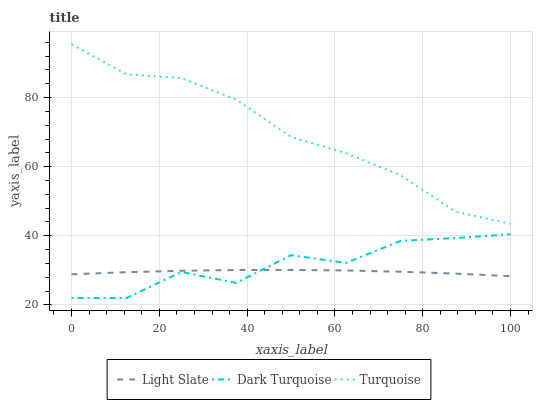Does Light Slate have the minimum area under the curve?
Answer yes or no. Yes. Does Turquoise have the maximum area under the curve?
Answer yes or no. Yes. Does Dark Turquoise have the minimum area under the curve?
Answer yes or no. No. Does Dark Turquoise have the maximum area under the curve?
Answer yes or no. No. Is Light Slate the smoothest?
Answer yes or no. Yes. Is Dark Turquoise the roughest?
Answer yes or no. Yes. Is Turquoise the smoothest?
Answer yes or no. No. Is Turquoise the roughest?
Answer yes or no. No. Does Dark Turquoise have the lowest value?
Answer yes or no. Yes. Does Turquoise have the lowest value?
Answer yes or no. No. Does Turquoise have the highest value?
Answer yes or no. Yes. Does Dark Turquoise have the highest value?
Answer yes or no. No. Is Dark Turquoise less than Turquoise?
Answer yes or no. Yes. Is Turquoise greater than Light Slate?
Answer yes or no. Yes. Does Light Slate intersect Dark Turquoise?
Answer yes or no. Yes. Is Light Slate less than Dark Turquoise?
Answer yes or no. No. Is Light Slate greater than Dark Turquoise?
Answer yes or no. No. Does Dark Turquoise intersect Turquoise?
Answer yes or no. No. 